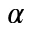<formula> <loc_0><loc_0><loc_500><loc_500>\alpha</formula> 